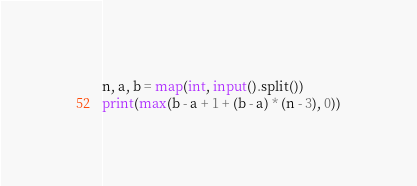Convert code to text. <code><loc_0><loc_0><loc_500><loc_500><_Python_>n, a, b = map(int, input().split())
print(max(b - a + 1 + (b - a) * (n - 3), 0))</code> 